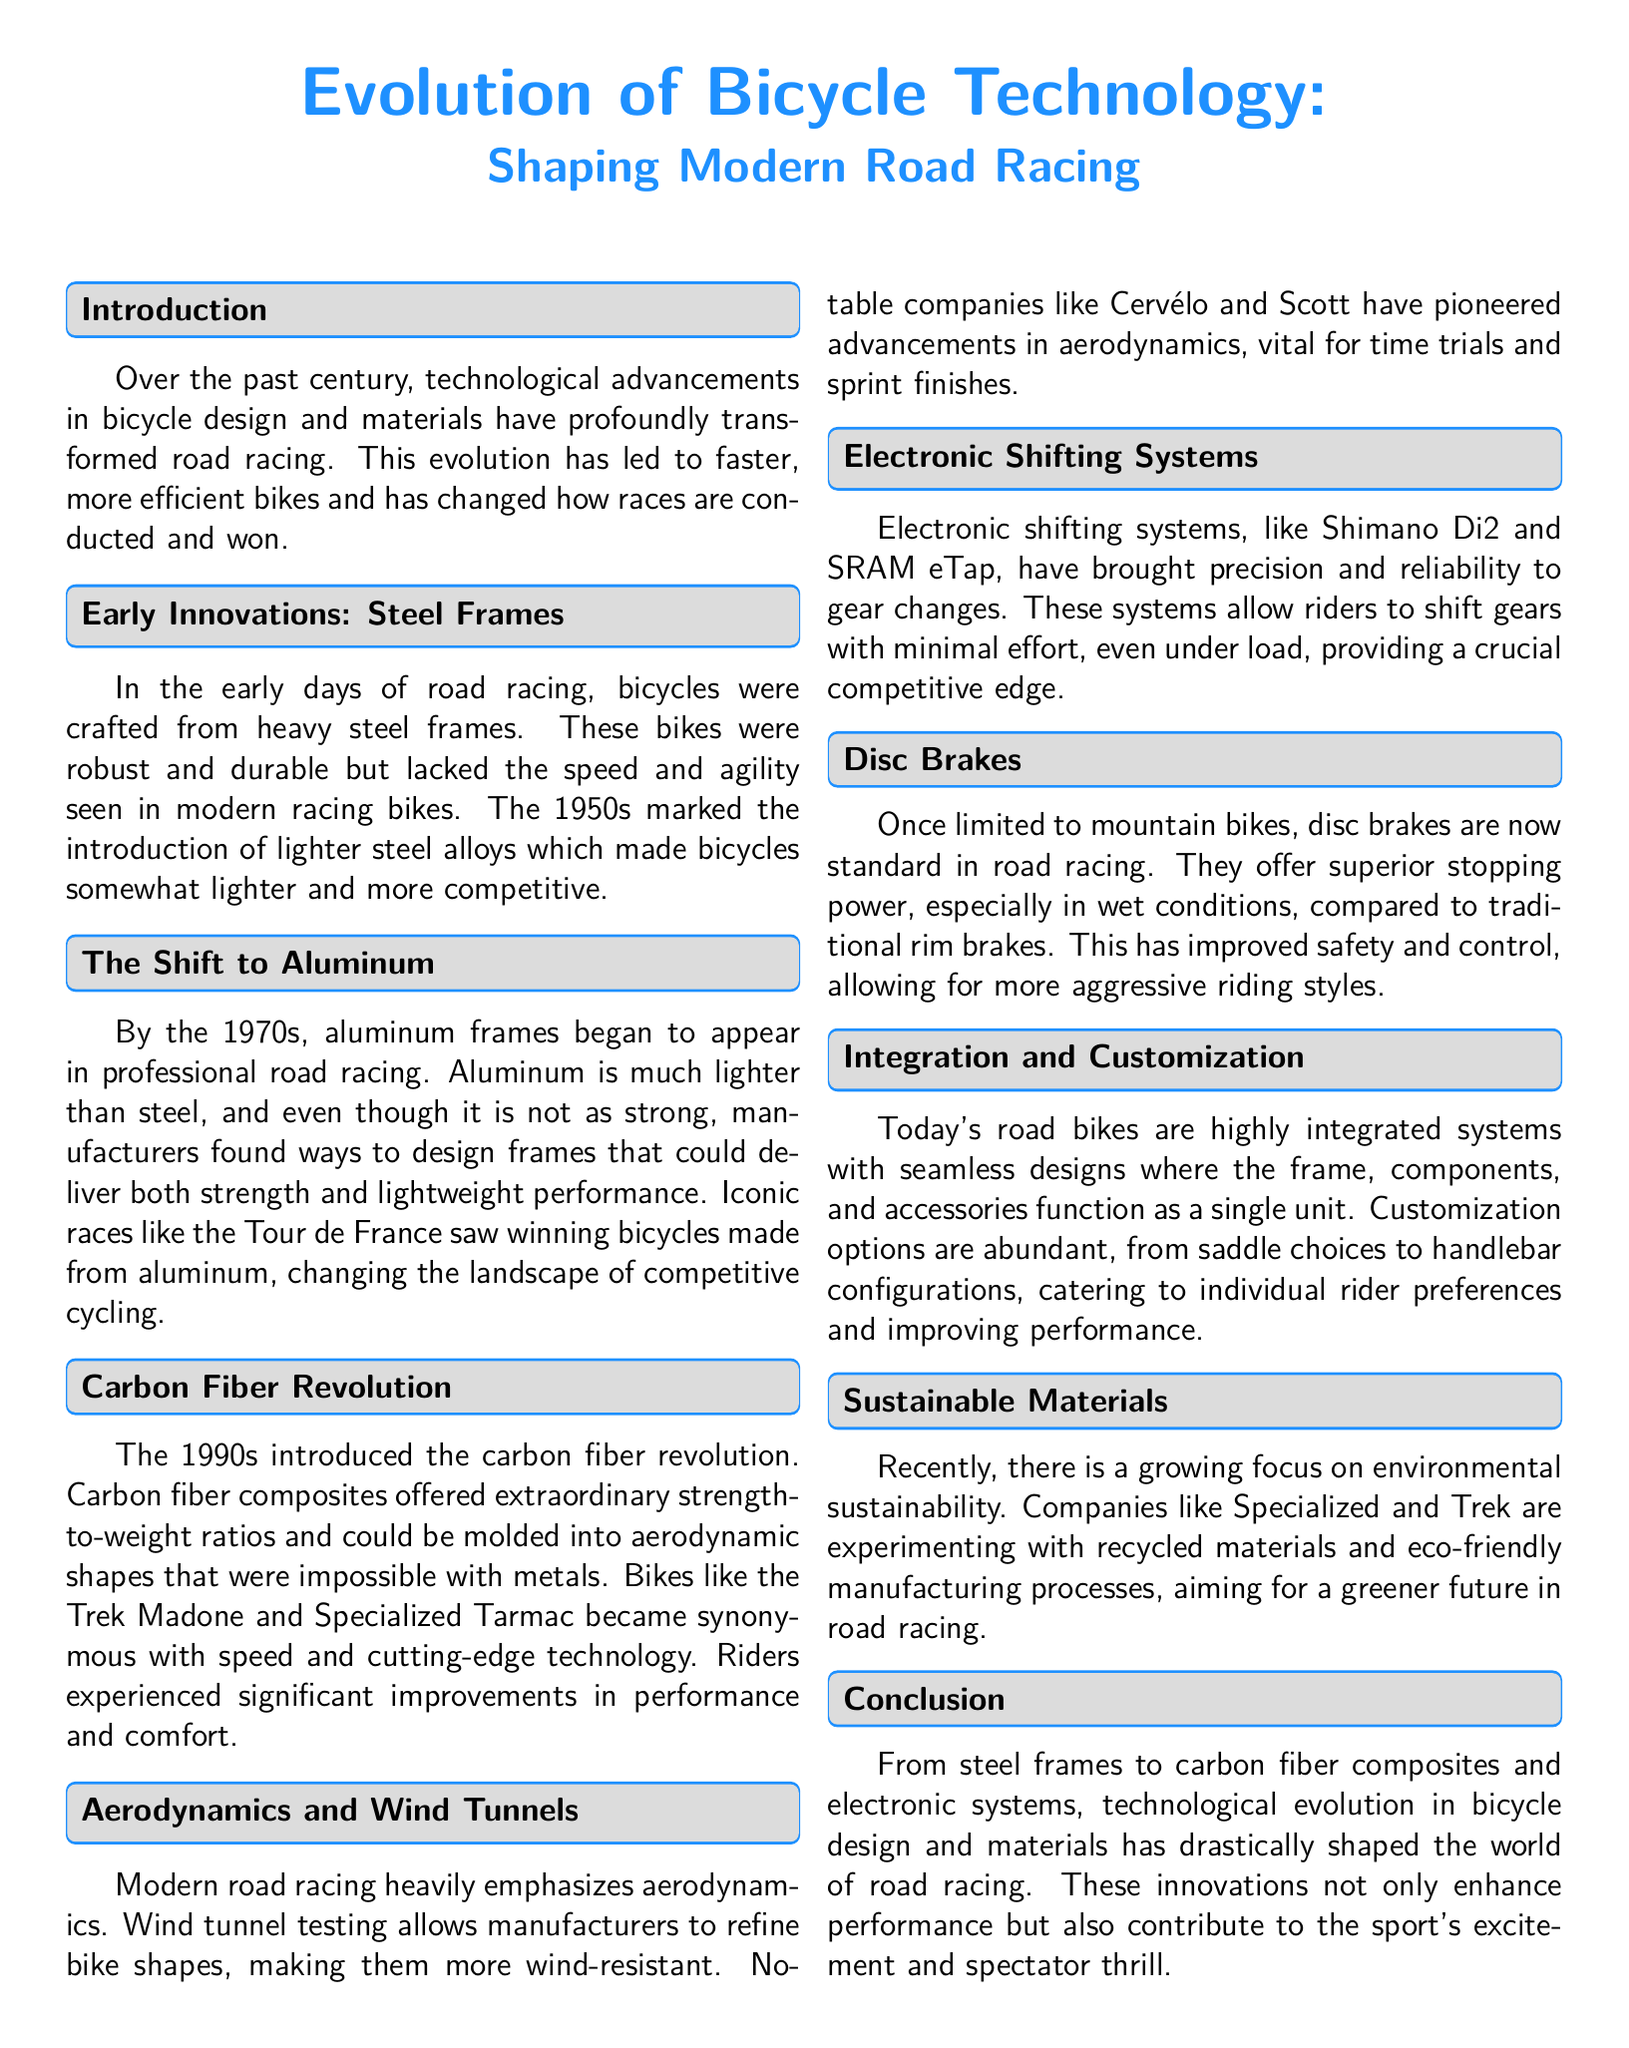What material were early road racing bicycles primarily made from? Early road racing bicycles were crafted from heavy steel frames.
Answer: Steel frames In which decade did aluminum frames start appearing in professional road racing? Aluminum frames began to appear in professional road racing in the 1970s.
Answer: 1970s What is the name of the bike model that became synonymous with speed and technology in the 1990s? The Trek Madone is a bike model that became synonymous with speed and cutting-edge technology.
Answer: Trek Madone What significant advantage do disc brakes offer compared to traditional rim brakes? Disc brakes offer superior stopping power, especially in wet conditions.
Answer: Superior stopping power Which two companies developed notable advancements in aerodynamics for road racing? Cervélo and Scott are companies that pioneered advancements in aerodynamics.
Answer: Cervélo and Scott What technology allows riders to shift gears with minimal effort? Electronic shifting systems allow riders to shift gears with minimal effort.
Answer: Electronic shifting systems What focus has been growing in recent years regarding bicycle manufacturing? There is a growing focus on environmental sustainability in bicycle manufacturing.
Answer: Environmental sustainability What type of analysis is used to refine bike shapes in modern road racing? Wind tunnel testing is used to refine bike shapes in modern road racing.
Answer: Wind tunnel testing 